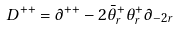Convert formula to latex. <formula><loc_0><loc_0><loc_500><loc_500>D ^ { + + } = \partial ^ { + + } - 2 \bar { \theta } ^ { + } _ { r } \theta ^ { + } _ { r } \partial _ { - 2 r }</formula> 